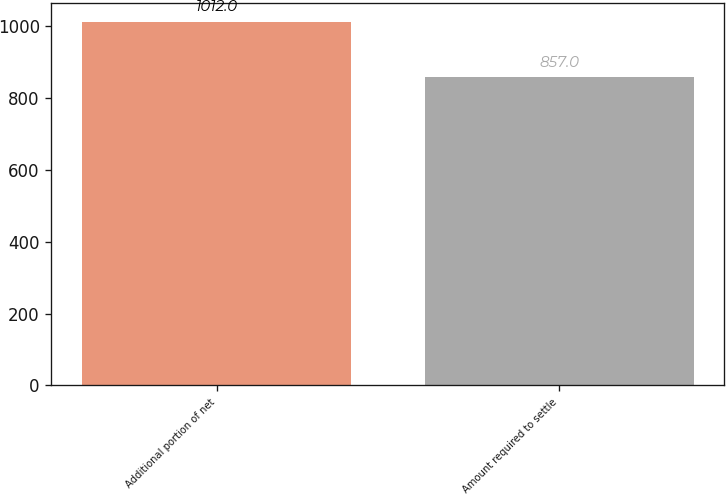Convert chart to OTSL. <chart><loc_0><loc_0><loc_500><loc_500><bar_chart><fcel>Additional portion of net<fcel>Amount required to settle<nl><fcel>1012<fcel>857<nl></chart> 